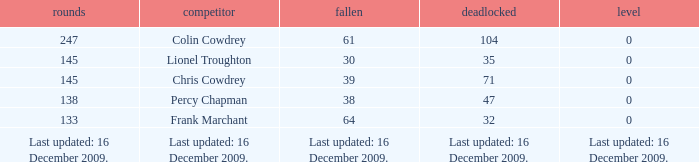Parse the full table. {'header': ['rounds', 'competitor', 'fallen', 'deadlocked', 'level'], 'rows': [['247', 'Colin Cowdrey', '61', '104', '0'], ['145', 'Lionel Troughton', '30', '35', '0'], ['145', 'Chris Cowdrey', '39', '71', '0'], ['138', 'Percy Chapman', '38', '47', '0'], ['133', 'Frank Marchant', '64', '32', '0'], ['Last updated: 16 December 2009.', 'Last updated: 16 December 2009.', 'Last updated: 16 December 2009.', 'Last updated: 16 December 2009.', 'Last updated: 16 December 2009.']]} Tell me the lost with tie of 0 and drawn of 47 38.0. 